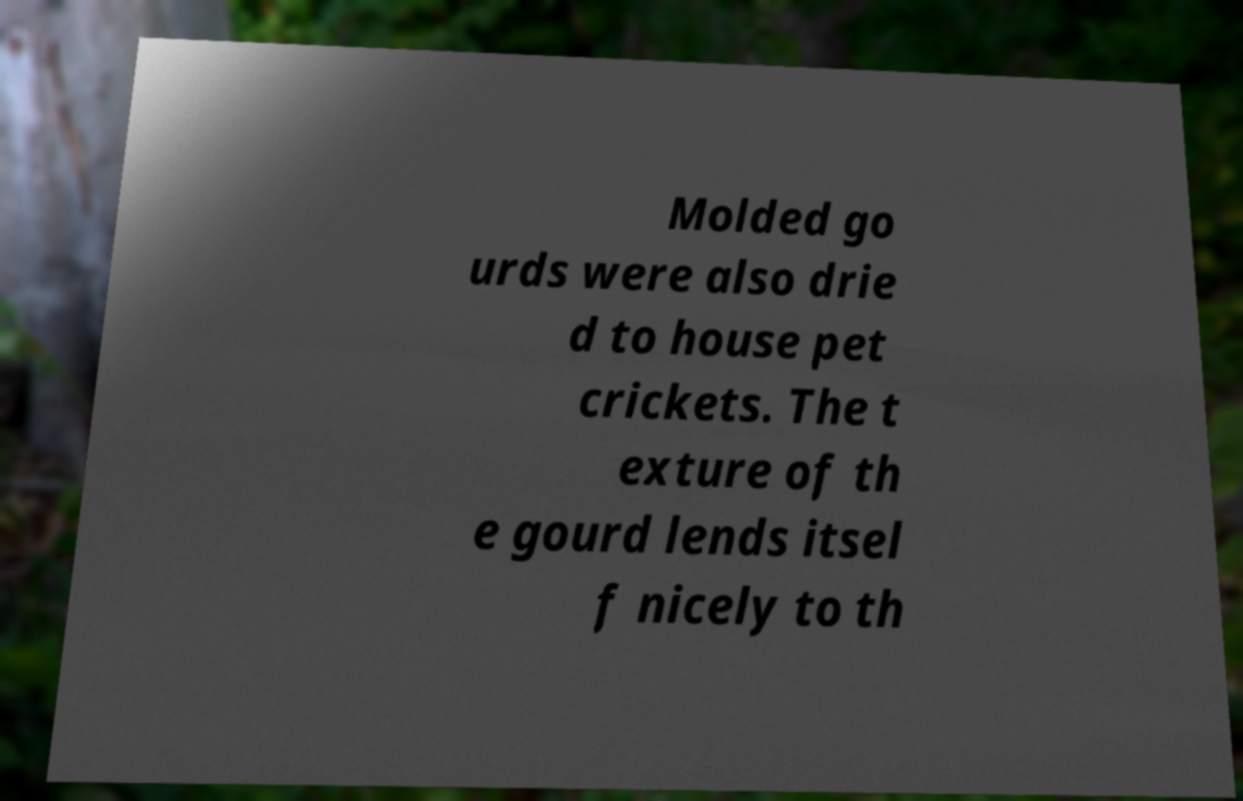For documentation purposes, I need the text within this image transcribed. Could you provide that? Molded go urds were also drie d to house pet crickets. The t exture of th e gourd lends itsel f nicely to th 